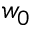Convert formula to latex. <formula><loc_0><loc_0><loc_500><loc_500>w _ { 0 }</formula> 